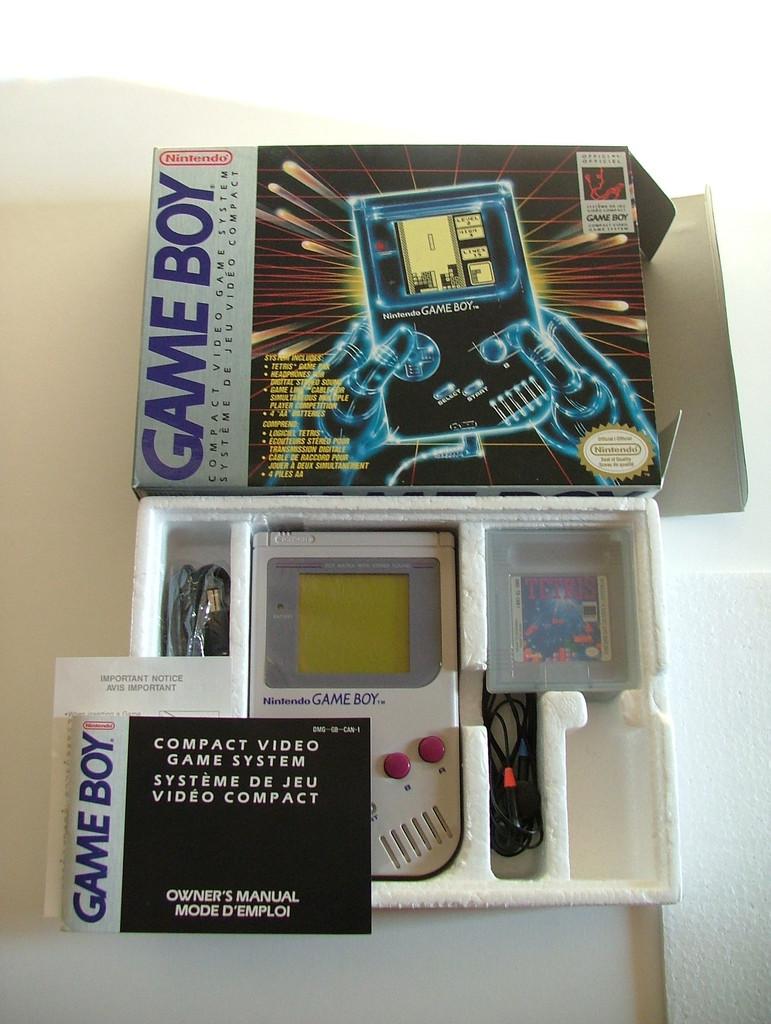What is the book in front of the game boy?
Your answer should be very brief. Owner's manual. 